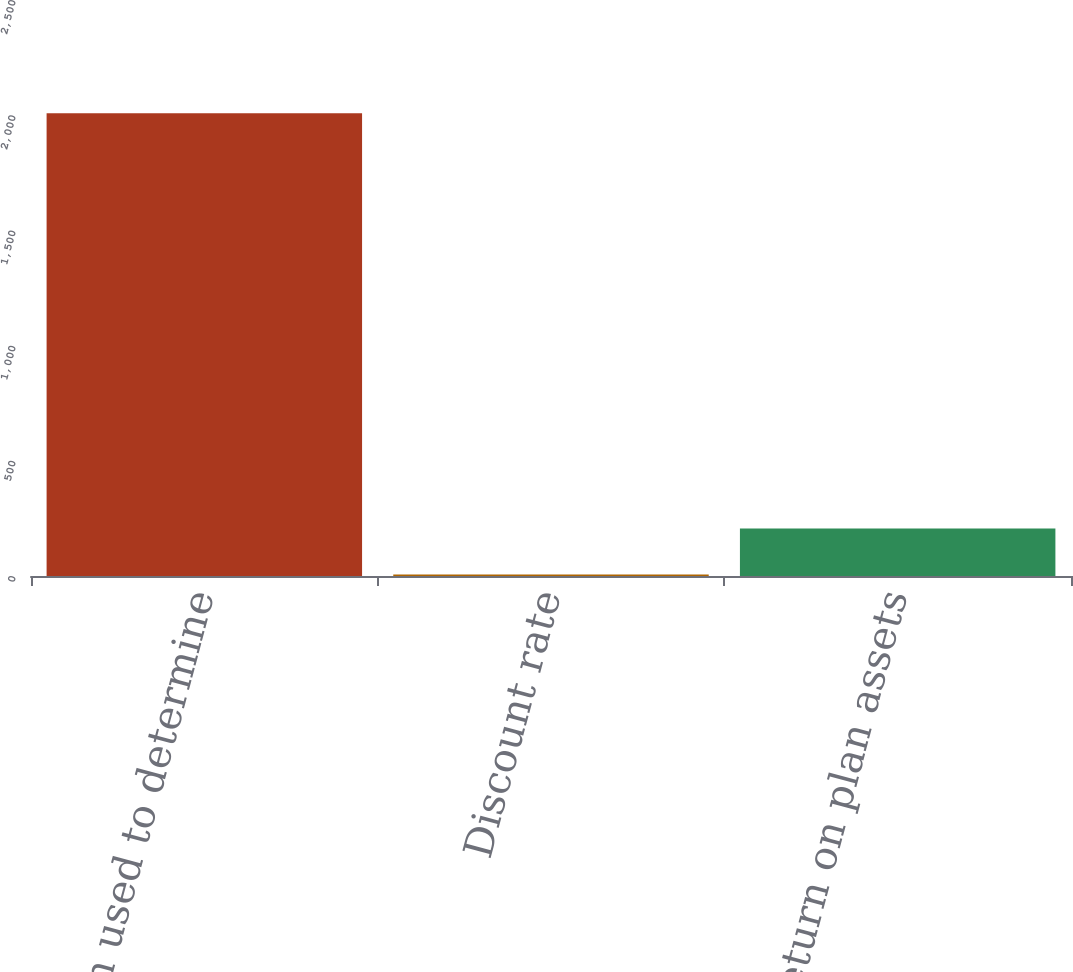<chart> <loc_0><loc_0><loc_500><loc_500><bar_chart><fcel>assumption used to determine<fcel>Discount rate<fcel>Expected return on plan assets<nl><fcel>2009<fcel>6<fcel>206.3<nl></chart> 